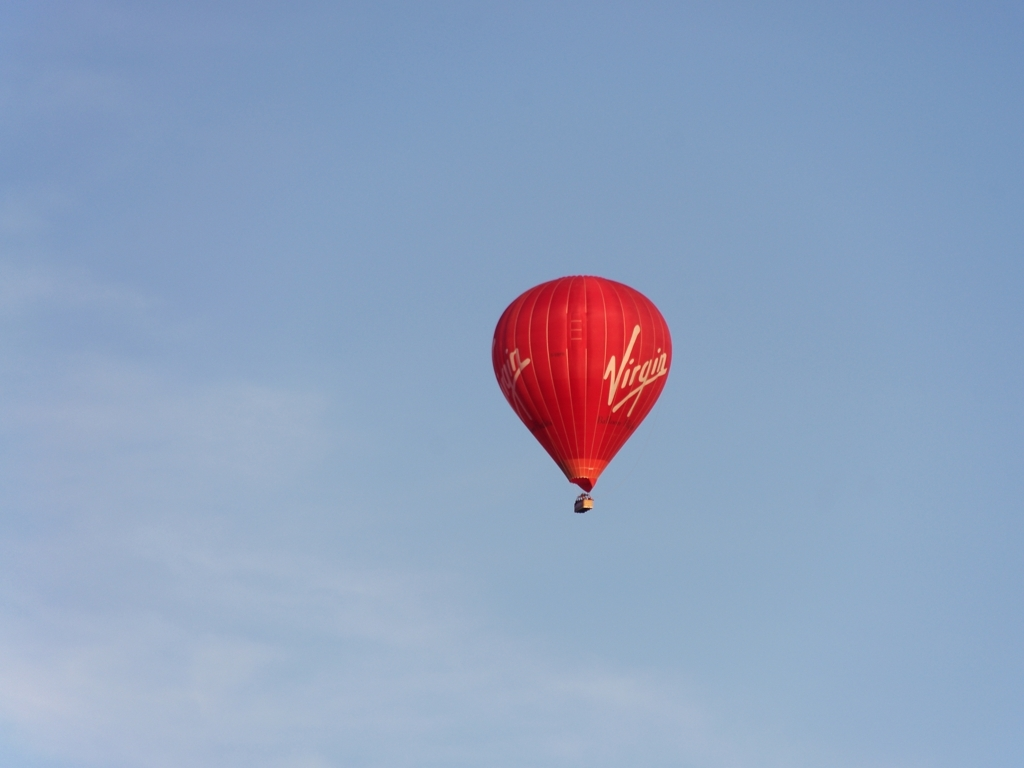Does the photo have rich details? The photo captures a red hot air balloon with 'Virgin' written on it, floating against a clear blue sky. While the color contrast is striking, the simplicity of the composition suggests a tranquil scene with minimal visual elements beyond the balloon itself. 